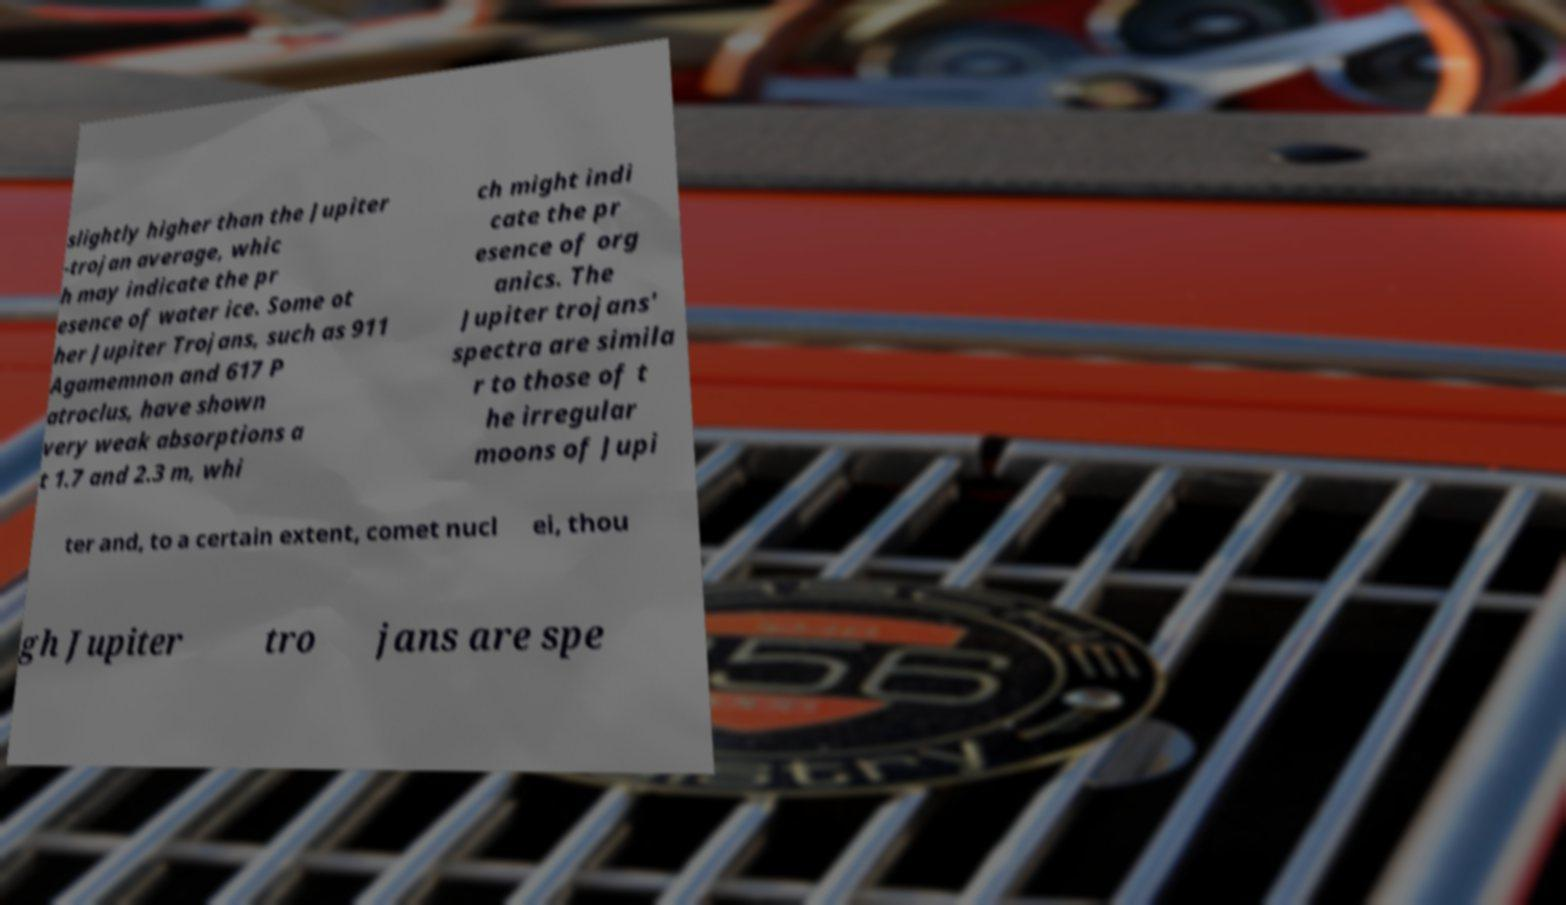Could you assist in decoding the text presented in this image and type it out clearly? slightly higher than the Jupiter -trojan average, whic h may indicate the pr esence of water ice. Some ot her Jupiter Trojans, such as 911 Agamemnon and 617 P atroclus, have shown very weak absorptions a t 1.7 and 2.3 m, whi ch might indi cate the pr esence of org anics. The Jupiter trojans' spectra are simila r to those of t he irregular moons of Jupi ter and, to a certain extent, comet nucl ei, thou gh Jupiter tro jans are spe 